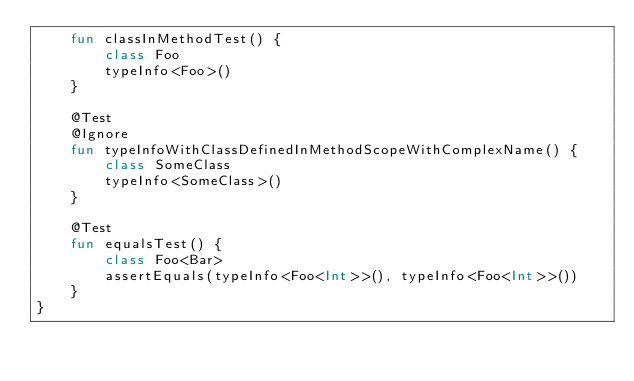Convert code to text. <code><loc_0><loc_0><loc_500><loc_500><_Kotlin_>    fun classInMethodTest() {
        class Foo
        typeInfo<Foo>()
    }

    @Test
    @Ignore
    fun typeInfoWithClassDefinedInMethodScopeWithComplexName() {
        class SomeClass
        typeInfo<SomeClass>()
    }

    @Test
    fun equalsTest() {
        class Foo<Bar>
        assertEquals(typeInfo<Foo<Int>>(), typeInfo<Foo<Int>>())
    }
}
</code> 